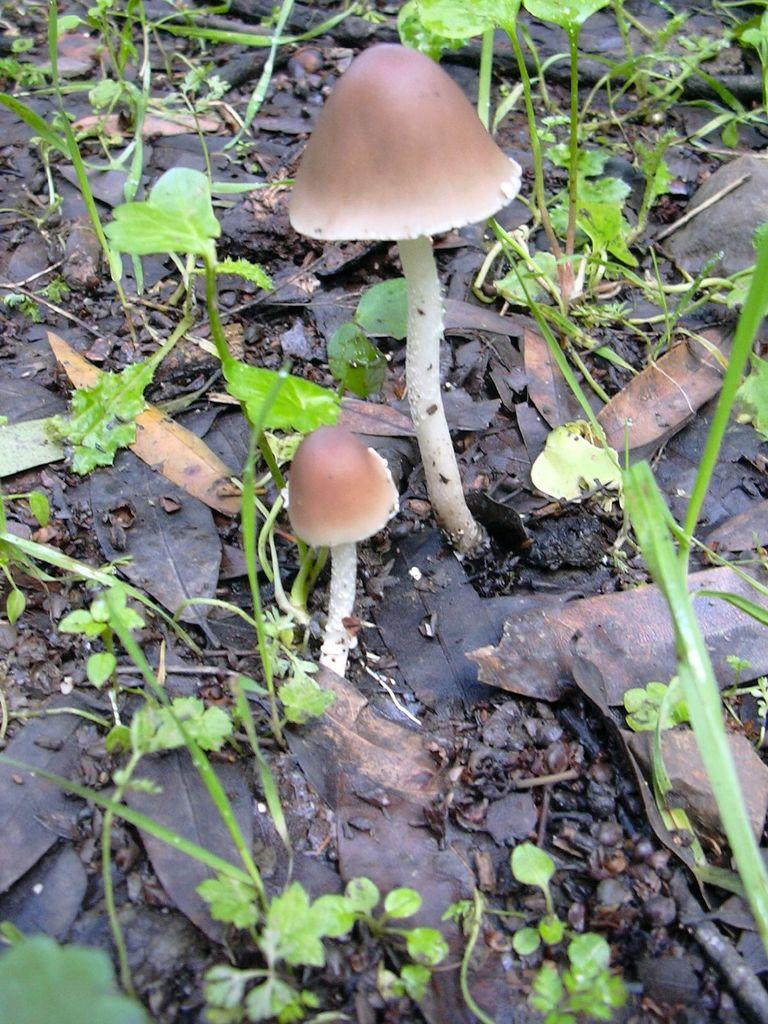How many mushrooms are present in the image? There are two mushrooms in the image. What other natural elements can be seen in the image? There are leaves, plants, and sticks on the ground in the image. What type of secretary is sitting behind the desk in the image? There is no secretary or desk present in the image; it features two mushrooms, leaves, plants, and sticks on the ground. 